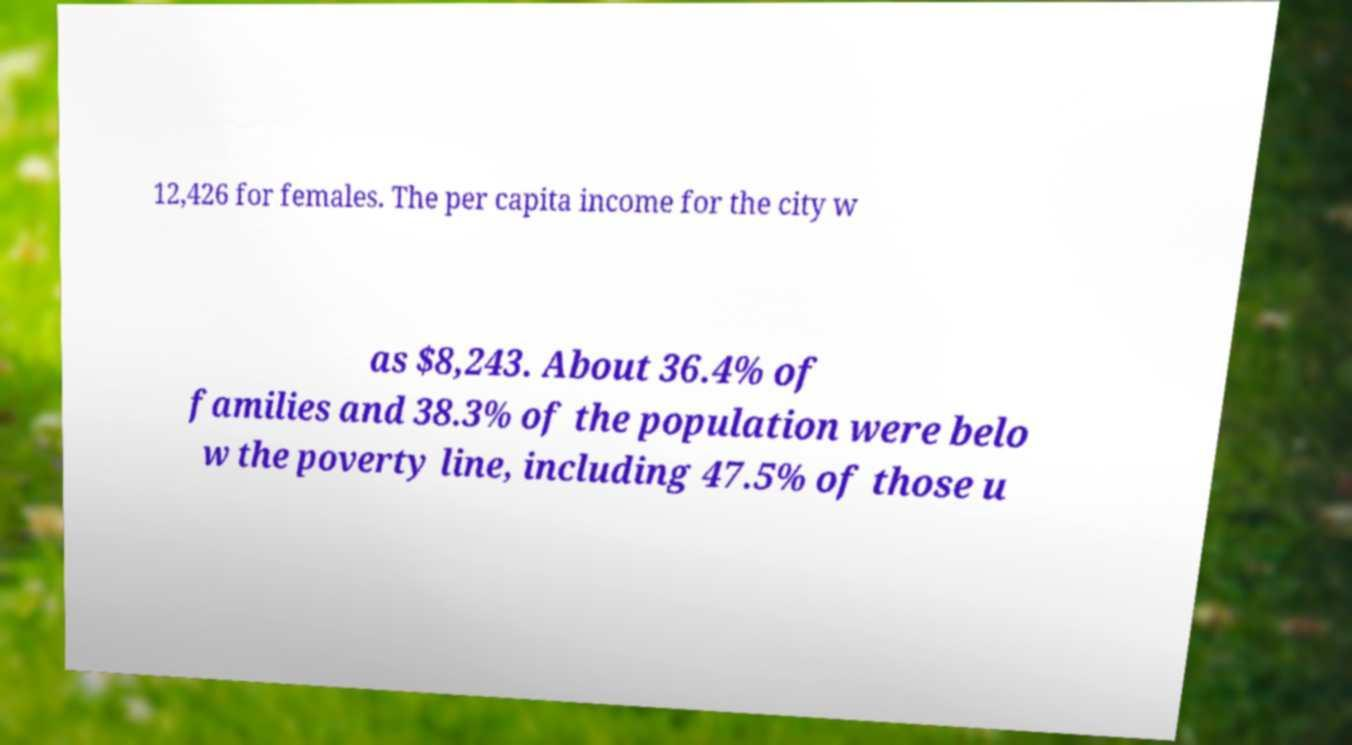There's text embedded in this image that I need extracted. Can you transcribe it verbatim? 12,426 for females. The per capita income for the city w as $8,243. About 36.4% of families and 38.3% of the population were belo w the poverty line, including 47.5% of those u 